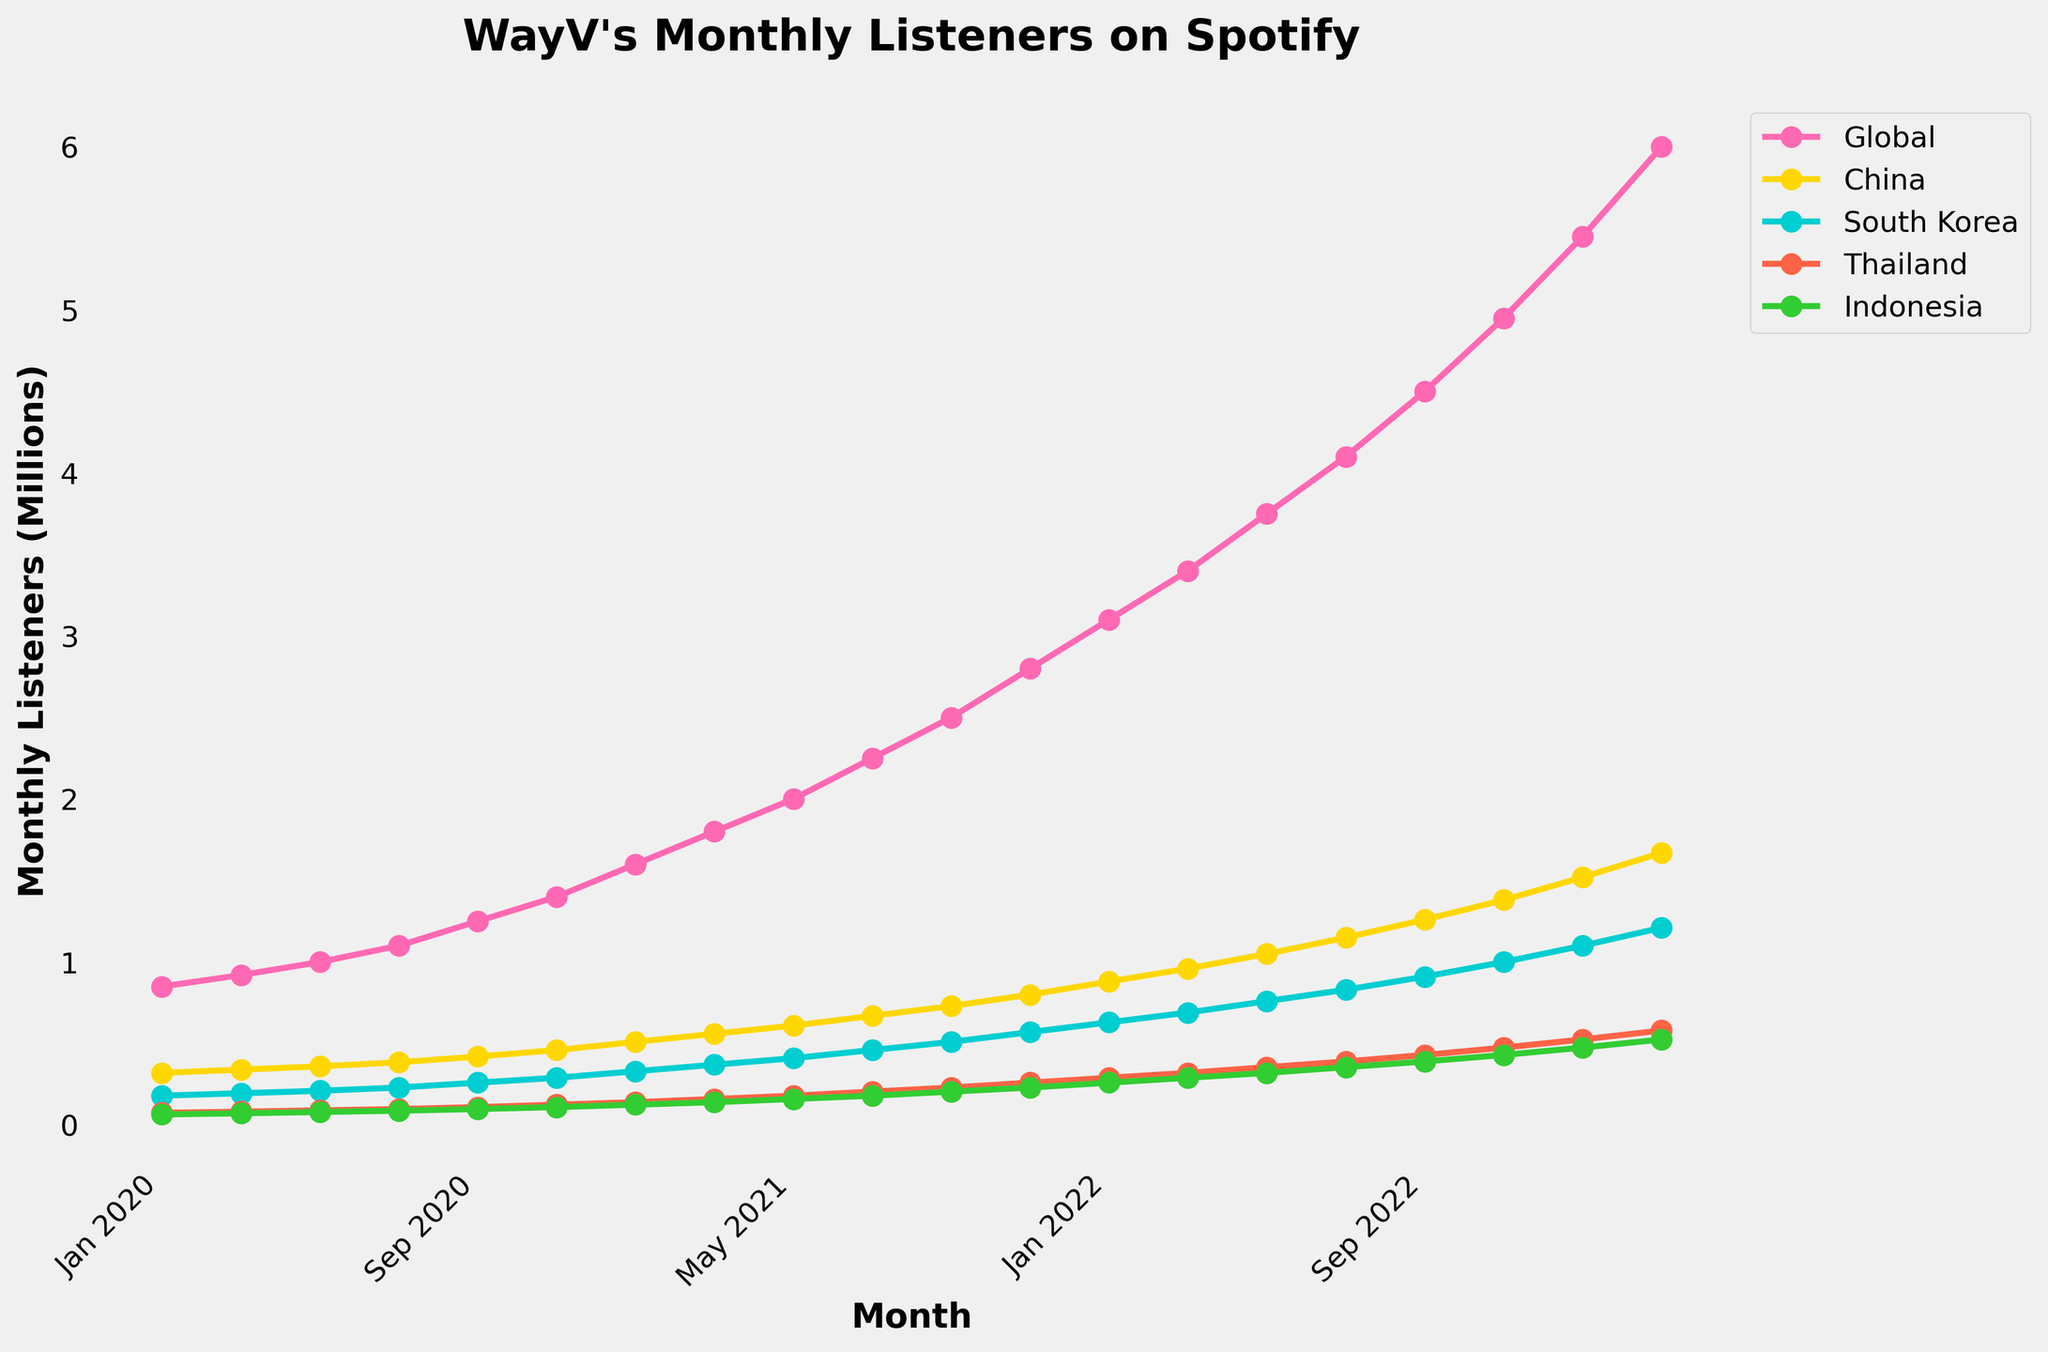Which month shows the highest number of monthly listeners globally? By examining the line plot for the "Global" line, the peak occurs in March 2023 as indicated by the highest point.
Answer: March 2023 In January 2021, which country had the lowest number of monthly listeners? Among the lines for January 2021, Singapore's line has the smallest value compared to the other countries listed.
Answer: Singapore How does the number of monthly listeners in South Korea in Jan 2022 compare to those in Thailand in Jan 2022? By comparing the heights of the lines, South Korea's value is higher than Thailand's in January 2022.
Answer: South Korea's value is higher What is the difference between the global monthly listeners in Nov 2022 and Jan 2023? The global value in Nov 2022 is 4.95 million, and in Jan 2023 it is 5.45 million. The difference is 5.45 - 4.95 million.
Answer: 0.5 million What trend do you observe for China's monthly listeners from Jan 2020 to Mar 2023? The "China" line consistently increases from Jan 2020 to Mar 2023, showing a steady upward trend.
Answer: Upward trend What rough rank order can you give for the top 3 countries by monthly listeners in Sep 2022? By visually assessing the height of lines in Sep 2022, China is highest, followed by South Korea, then Thailand.
Answer: China, South Korea, Thailand Which country had a closer number of monthly listeners to the US in Jan 2021, Indonesia or Japan? By observing the proximity of the lines for Indonesia and Japan to the US in Jan 2021, Japan is closer.
Answer: Japan How much did the monthly listeners in the Philippines grow from Nov 2020 to Mar 2022? In Nov 2020 the value is 105,000, and in Mar 2022 it is 285,000, resulting in a growth of 285,000 - 105,000.
Answer: 180,000 Between which months does the Global line show the sharpest increase in monthly listeners? The sharpest increase for the "Global" line appears between Jan 2023 and Mar 2023 by inspecting the steepest slope.
Answer: Jan 2023 to Mar 2023 